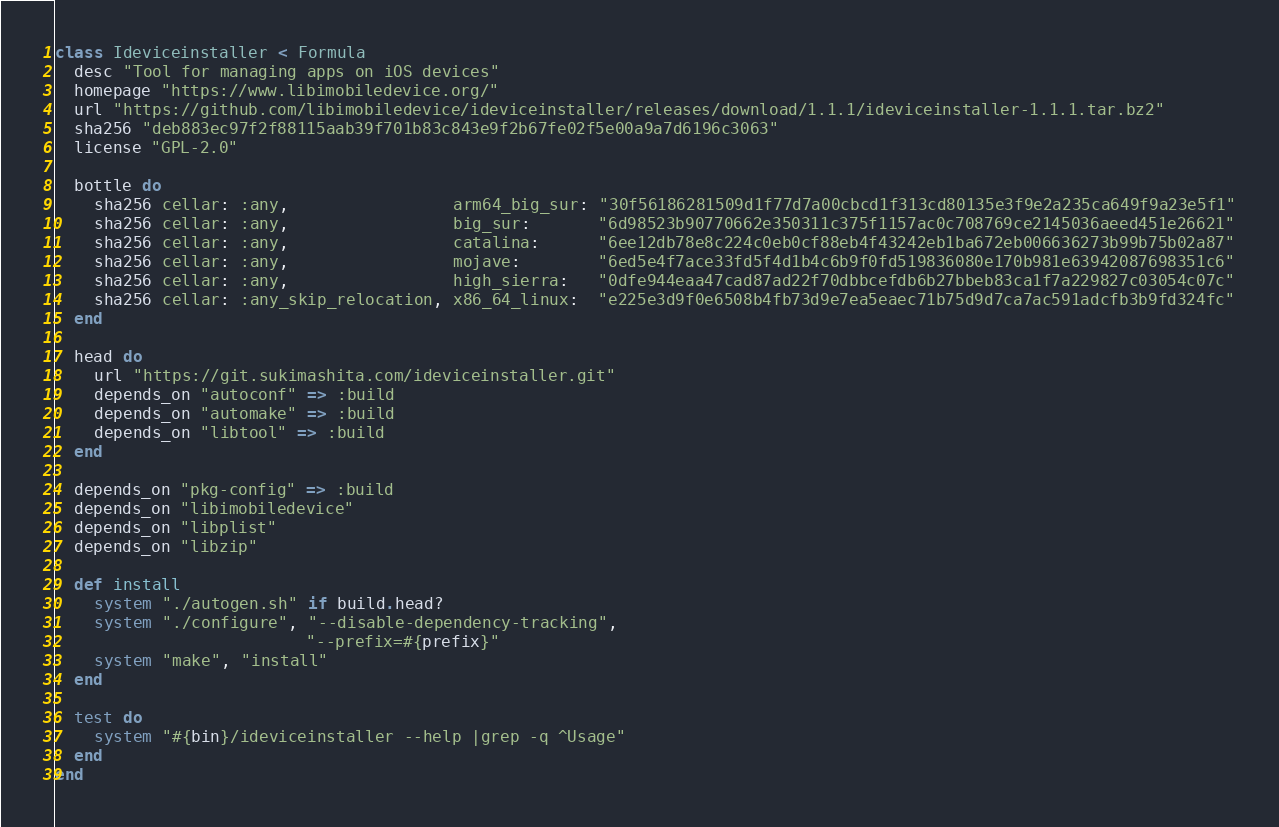Convert code to text. <code><loc_0><loc_0><loc_500><loc_500><_Ruby_>class Ideviceinstaller < Formula
  desc "Tool for managing apps on iOS devices"
  homepage "https://www.libimobiledevice.org/"
  url "https://github.com/libimobiledevice/ideviceinstaller/releases/download/1.1.1/ideviceinstaller-1.1.1.tar.bz2"
  sha256 "deb883ec97f2f88115aab39f701b83c843e9f2b67fe02f5e00a9a7d6196c3063"
  license "GPL-2.0"

  bottle do
    sha256 cellar: :any,                 arm64_big_sur: "30f56186281509d1f77d7a00cbcd1f313cd80135e3f9e2a235ca649f9a23e5f1"
    sha256 cellar: :any,                 big_sur:       "6d98523b90770662e350311c375f1157ac0c708769ce2145036aeed451e26621"
    sha256 cellar: :any,                 catalina:      "6ee12db78e8c224c0eb0cf88eb4f43242eb1ba672eb006636273b99b75b02a87"
    sha256 cellar: :any,                 mojave:        "6ed5e4f7ace33fd5f4d1b4c6b9f0fd519836080e170b981e63942087698351c6"
    sha256 cellar: :any,                 high_sierra:   "0dfe944eaa47cad87ad22f70dbbcefdb6b27bbeb83ca1f7a229827c03054c07c"
    sha256 cellar: :any_skip_relocation, x86_64_linux:  "e225e3d9f0e6508b4fb73d9e7ea5eaec71b75d9d7ca7ac591adcfb3b9fd324fc"
  end

  head do
    url "https://git.sukimashita.com/ideviceinstaller.git"
    depends_on "autoconf" => :build
    depends_on "automake" => :build
    depends_on "libtool" => :build
  end

  depends_on "pkg-config" => :build
  depends_on "libimobiledevice"
  depends_on "libplist"
  depends_on "libzip"

  def install
    system "./autogen.sh" if build.head?
    system "./configure", "--disable-dependency-tracking",
                          "--prefix=#{prefix}"
    system "make", "install"
  end

  test do
    system "#{bin}/ideviceinstaller --help |grep -q ^Usage"
  end
end
</code> 